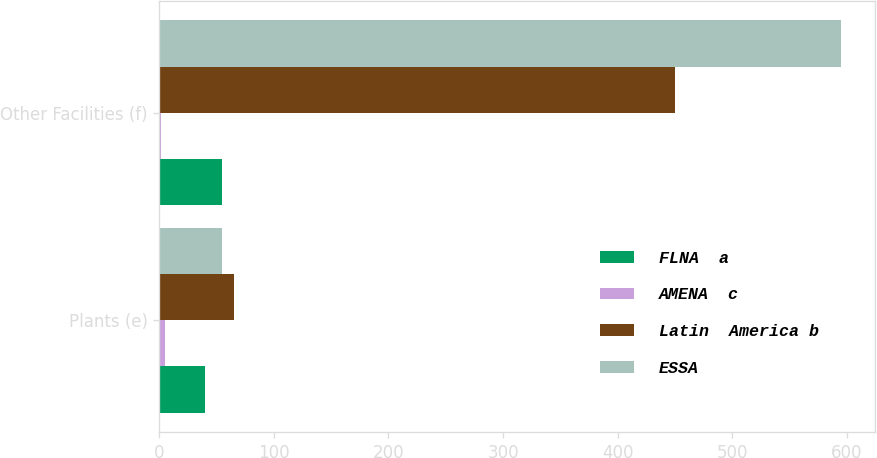Convert chart to OTSL. <chart><loc_0><loc_0><loc_500><loc_500><stacked_bar_chart><ecel><fcel>Plants (e)<fcel>Other Facilities (f)<nl><fcel>FLNA  a<fcel>40<fcel>55<nl><fcel>AMENA  c<fcel>5<fcel>2<nl><fcel>Latin  America b<fcel>65<fcel>450<nl><fcel>ESSA<fcel>55<fcel>595<nl></chart> 